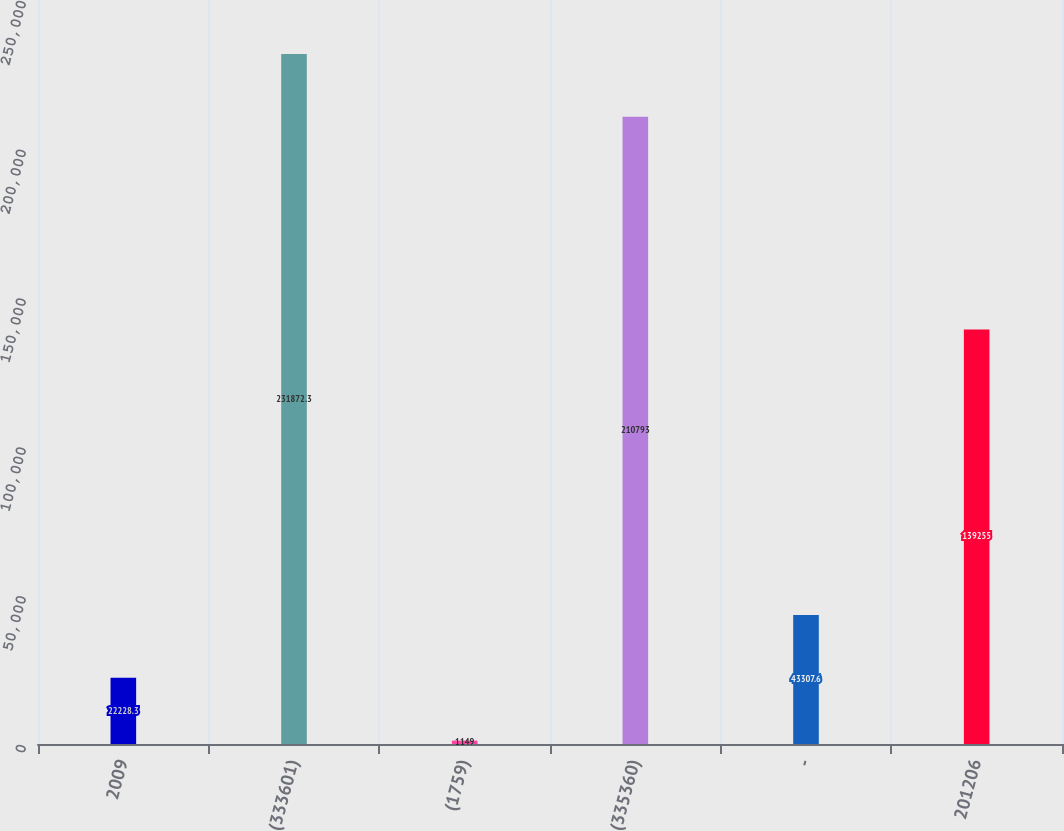Convert chart to OTSL. <chart><loc_0><loc_0><loc_500><loc_500><bar_chart><fcel>2009<fcel>(333601)<fcel>(1759)<fcel>(335360)<fcel>-<fcel>201206<nl><fcel>22228.3<fcel>231872<fcel>1149<fcel>210793<fcel>43307.6<fcel>139255<nl></chart> 